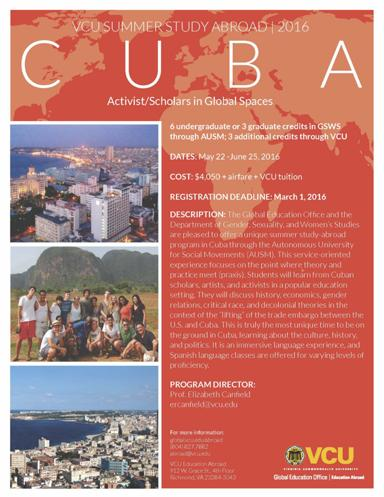What are the dates for this program, and what is the cost? The 'VCU Summer Study Abroad 2016' program in Cuba runs from May 22 to June 25, 2016. The cost for this enriching educational experience is 4,050 dollars, which covers program fees but excludes airfare and VCU tuition, allowing students to manage additional travel expenses and educational costs effectively. 